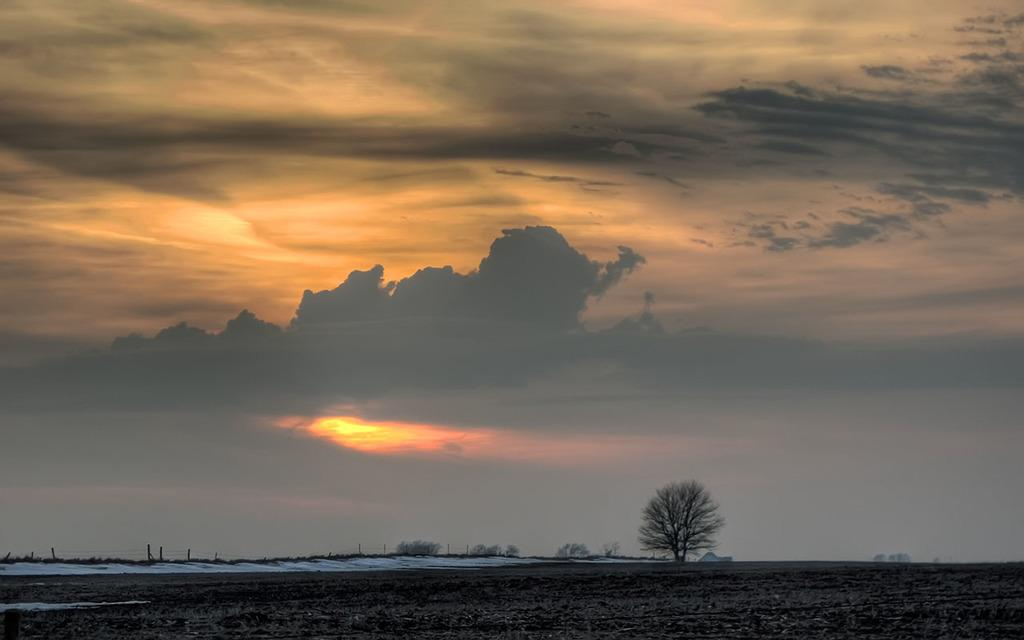What type of surface can be seen in the image? There is ground visible in the image. What type of vegetation is present in the image? There are trees in the image. What structures can be seen in the image? There are poles and a house in the image. What is visible in the background of the image? The sky is visible in the background of the image. What can be observed in the sky? Clouds are present in the sky. What type of vase is placed on the roof of the house in the image? There is no vase present on the roof of the house in the image. What color is the paint used on the poles in the image? The provided facts do not mention the color of the paint used on the poles in the image. Is there a minister present in the image? There is no mention of a minister or any person in the image. 